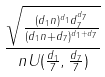<formula> <loc_0><loc_0><loc_500><loc_500>\frac { \sqrt { \frac { ( d _ { 1 } n ) ^ { d _ { 1 } } d _ { 7 } ^ { d _ { 7 } } } { ( d _ { 1 } n + d _ { 7 } ) ^ { d _ { 1 } + d _ { 7 } } } } } { n U ( \frac { d _ { 1 } } { 7 } , \frac { d _ { 7 } } { 7 } ) }</formula> 